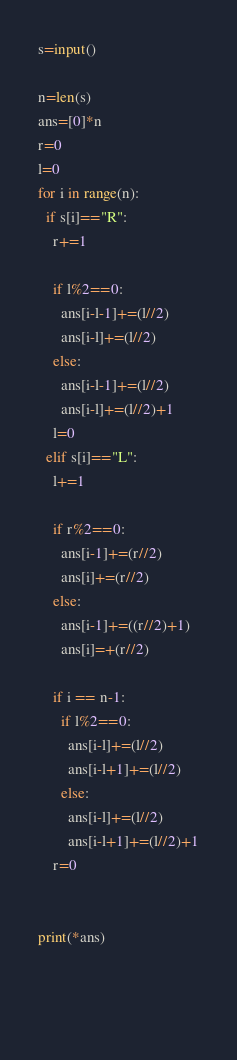Convert code to text. <code><loc_0><loc_0><loc_500><loc_500><_Python_>s=input()

n=len(s)
ans=[0]*n
r=0
l=0
for i in range(n):
  if s[i]=="R":
    r+=1
    
    if l%2==0:
      ans[i-l-1]+=(l//2)
      ans[i-l]+=(l//2)
    else:
      ans[i-l-1]+=(l//2)
      ans[i-l]+=(l//2)+1    
    l=0
  elif s[i]=="L":
    l+=1
    
    if r%2==0:
      ans[i-1]+=(r//2)
      ans[i]+=(r//2)
    else:
      ans[i-1]+=((r//2)+1)
      ans[i]=+(r//2)
      
    if i == n-1:
      if l%2==0:
        ans[i-l]+=(l//2)
        ans[i-l+1]+=(l//2)
      else:
        ans[i-l]+=(l//2)
        ans[i-l+1]+=(l//2)+1
    r=0

    
print(*ans)

    
    </code> 